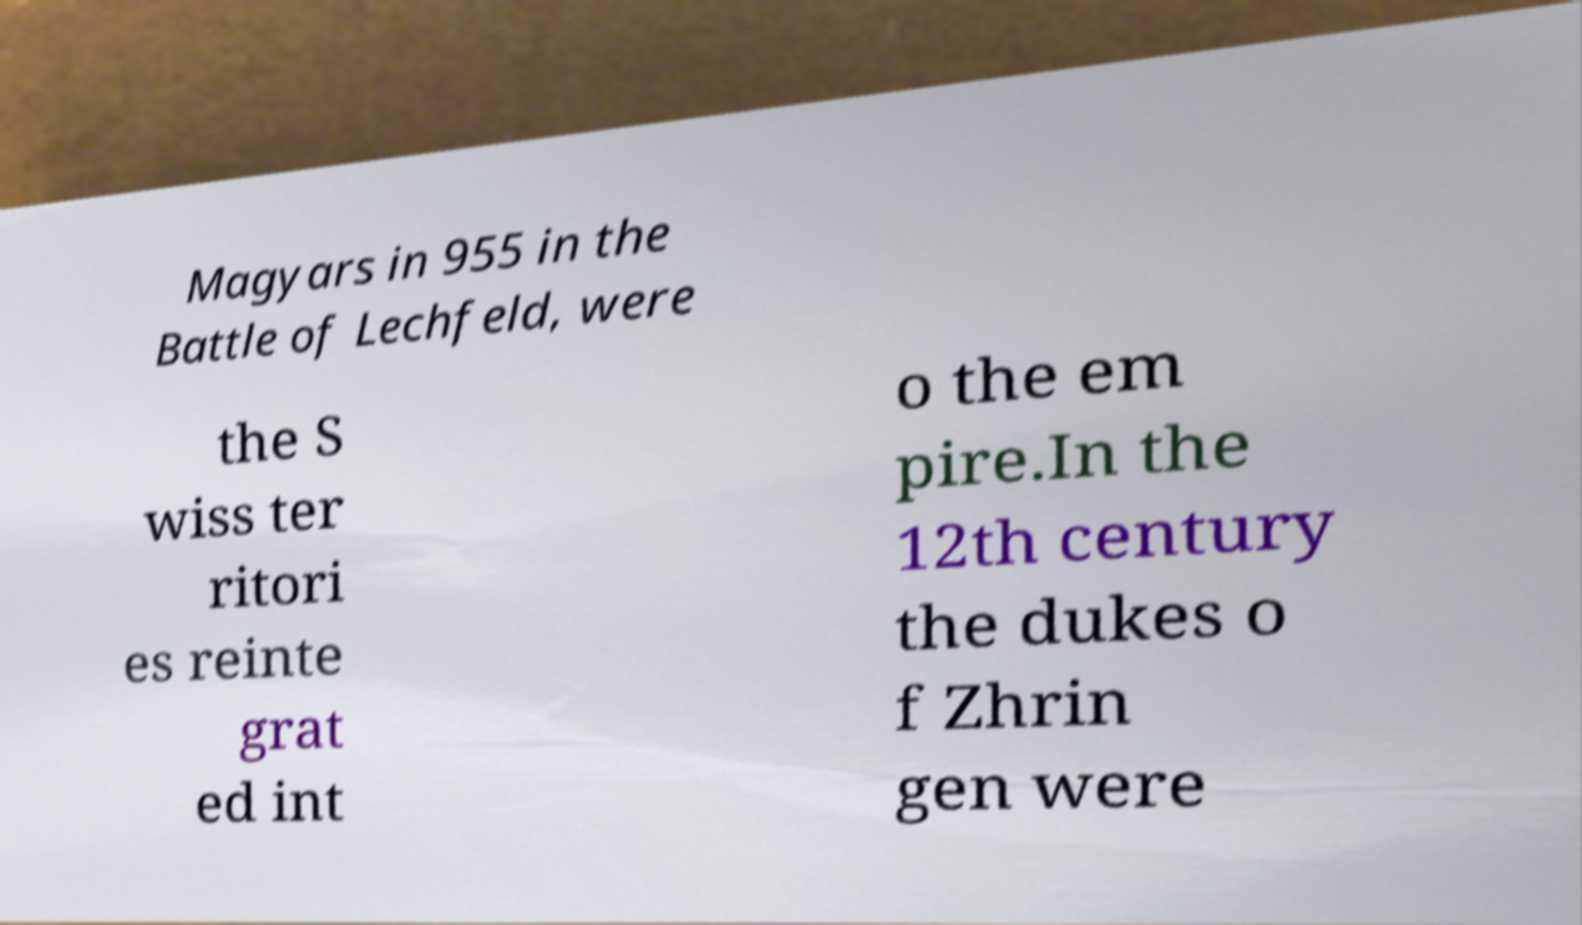Please identify and transcribe the text found in this image. Magyars in 955 in the Battle of Lechfeld, were the S wiss ter ritori es reinte grat ed int o the em pire.In the 12th century the dukes o f Zhrin gen were 